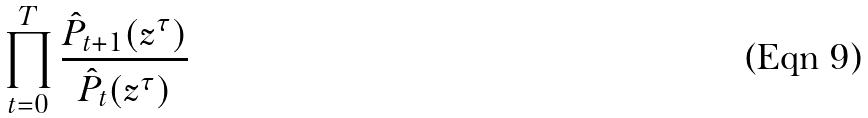Convert formula to latex. <formula><loc_0><loc_0><loc_500><loc_500>\prod _ { t = 0 } ^ { T } \frac { \hat { P } _ { t + 1 } ( z ^ { \tau } ) } { \hat { P } _ { t } ( z ^ { \tau } ) }</formula> 